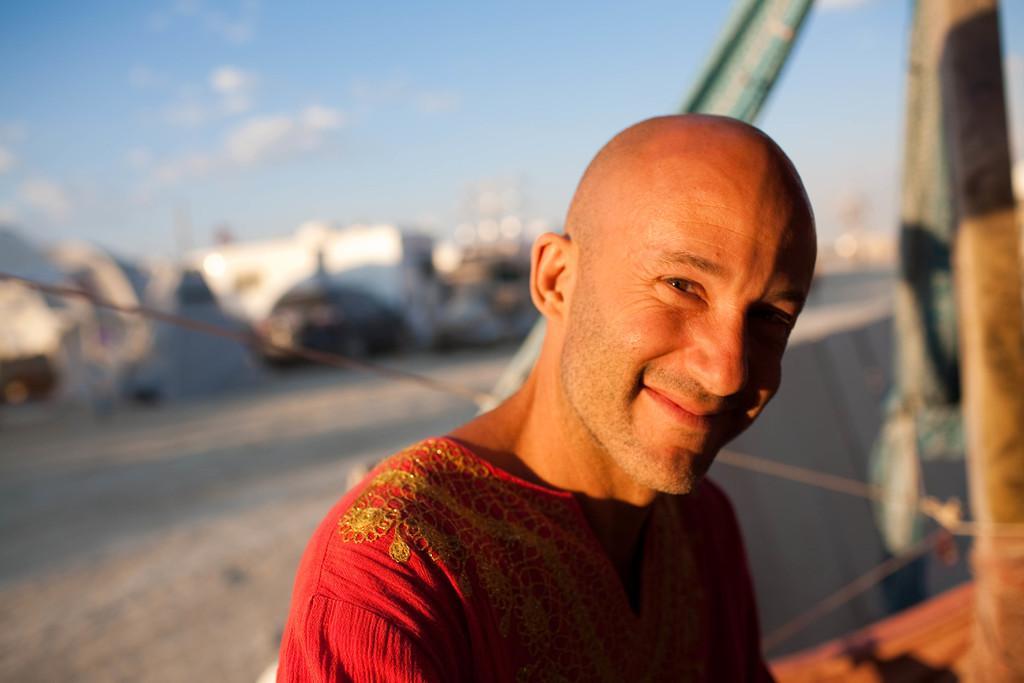In one or two sentences, can you explain what this image depicts? In this image there is a person in the foreground. There is an object on the right corner. There is a vehicle in the background. There is sky at the top. 